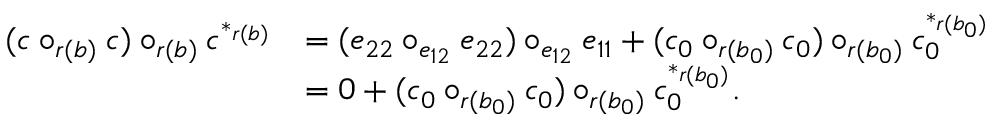Convert formula to latex. <formula><loc_0><loc_0><loc_500><loc_500>\begin{array} { r l } { ( c \circ _ { r ( b ) } c ) \circ _ { r ( b ) } c ^ { * _ { r ( b ) } } } & { = ( e _ { 2 2 } \circ _ { e _ { 1 2 } } e _ { 2 2 } ) \circ _ { e _ { 1 2 } } e _ { 1 1 } + ( c _ { 0 } \circ _ { r ( b _ { 0 } ) } c _ { 0 } ) \circ _ { r ( b _ { 0 } ) } c _ { 0 } ^ { * _ { r ( b _ { 0 } ) } } } \\ & { = 0 + ( c _ { 0 } \circ _ { r ( b _ { 0 } ) } c _ { 0 } ) \circ _ { r ( b _ { 0 } ) } c _ { 0 } ^ { * _ { r ( b _ { 0 } ) } } . } \end{array}</formula> 